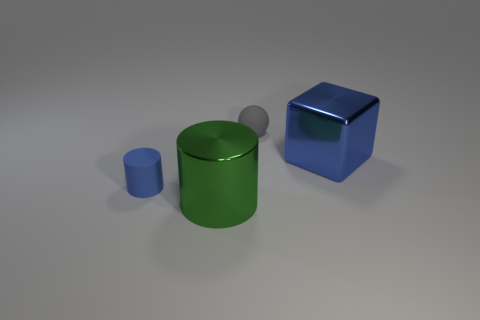Is the blue cylinder made of the same material as the tiny gray sphere?
Your response must be concise. Yes. There is a big green thing that is made of the same material as the big cube; what is its shape?
Give a very brief answer. Cylinder. Is there anything else of the same color as the large metal cube?
Give a very brief answer. Yes. What color is the large shiny thing to the right of the large green metal cylinder?
Offer a very short reply. Blue. Do the tiny rubber thing in front of the large blue object and the block have the same color?
Your answer should be very brief. Yes. There is another thing that is the same shape as the tiny blue thing; what is it made of?
Provide a succinct answer. Metal. How many gray matte things have the same size as the blue metal object?
Your answer should be very brief. 0. What is the shape of the large blue object?
Give a very brief answer. Cube. What is the size of the object that is on the left side of the gray thing and on the right side of the tiny blue cylinder?
Keep it short and to the point. Large. What material is the large block that is in front of the gray rubber sphere?
Your answer should be very brief. Metal. 